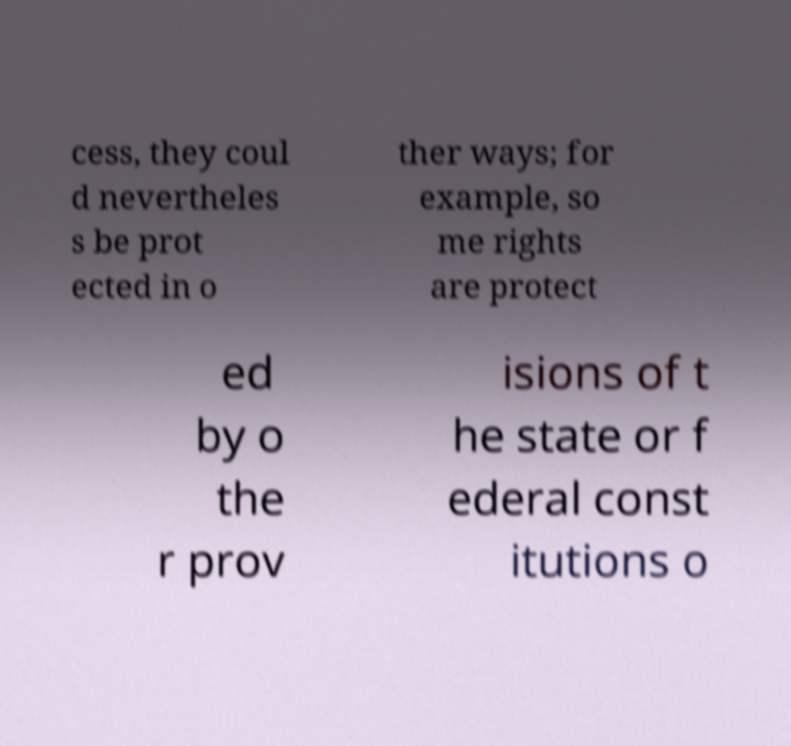What messages or text are displayed in this image? I need them in a readable, typed format. cess, they coul d nevertheles s be prot ected in o ther ways; for example, so me rights are protect ed by o the r prov isions of t he state or f ederal const itutions o 